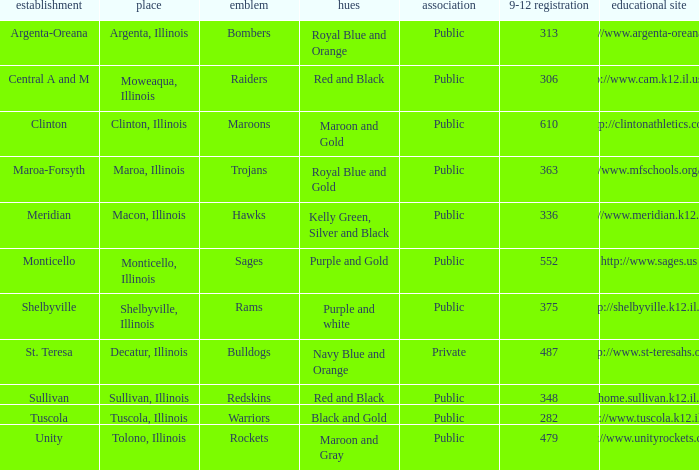What's the website of the school in Macon, Illinois? Http://www.meridian.k12.il.us/. 